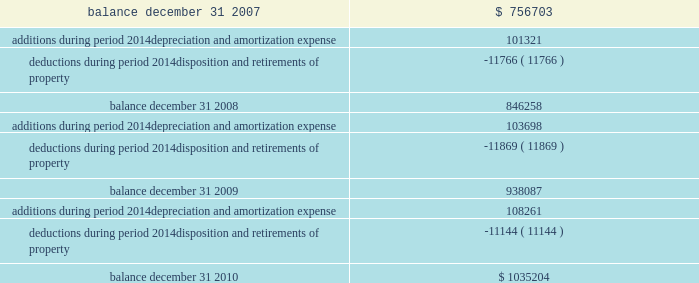Federal realty investment trust schedule iii summary of real estate and accumulated depreciation 2014continued three years ended december 31 , 2010 reconciliation of accumulated depreciation and amortization ( in thousands ) .

Considering the years 2009-2010 , what is the increase in the final balance? 
Rationale: it is the balance at 2010 divided by the one at 2009 , then turned into a percentage .
Computations: ((1035204 / 938087) - 1)
Answer: 0.10353. 